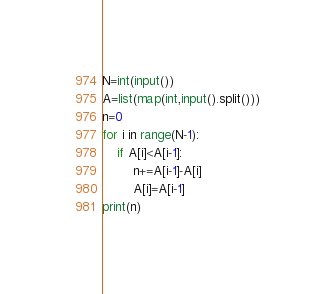Convert code to text. <code><loc_0><loc_0><loc_500><loc_500><_Python_>N=int(input())
A=list(map(int,input().split()))
n=0
for i in range(N-1):    
    if A[i]<A[i-1]:
        n+=A[i-1]-A[i]
        A[i]=A[i-1]
print(n)
</code> 